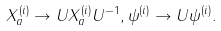<formula> <loc_0><loc_0><loc_500><loc_500>X _ { a } ^ { ( i ) } \rightarrow U X _ { a } ^ { ( i ) } U ^ { - 1 } , \psi ^ { ( i ) } \rightarrow U \psi ^ { ( i ) } .</formula> 